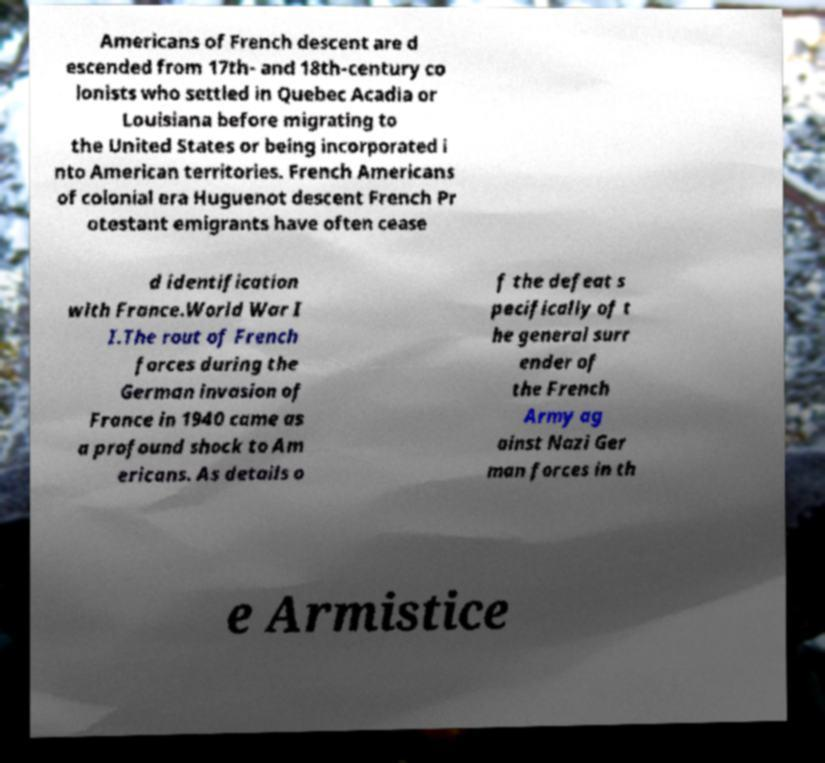For documentation purposes, I need the text within this image transcribed. Could you provide that? Americans of French descent are d escended from 17th- and 18th-century co lonists who settled in Quebec Acadia or Louisiana before migrating to the United States or being incorporated i nto American territories. French Americans of colonial era Huguenot descent French Pr otestant emigrants have often cease d identification with France.World War I I.The rout of French forces during the German invasion of France in 1940 came as a profound shock to Am ericans. As details o f the defeat s pecifically of t he general surr ender of the French Army ag ainst Nazi Ger man forces in th e Armistice 